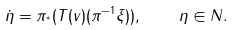Convert formula to latex. <formula><loc_0><loc_0><loc_500><loc_500>\dot { \eta } = \pi _ { ^ { * } } ( T ( v ) ( \pi ^ { - 1 } \xi ) ) , \quad \eta \in N .</formula> 